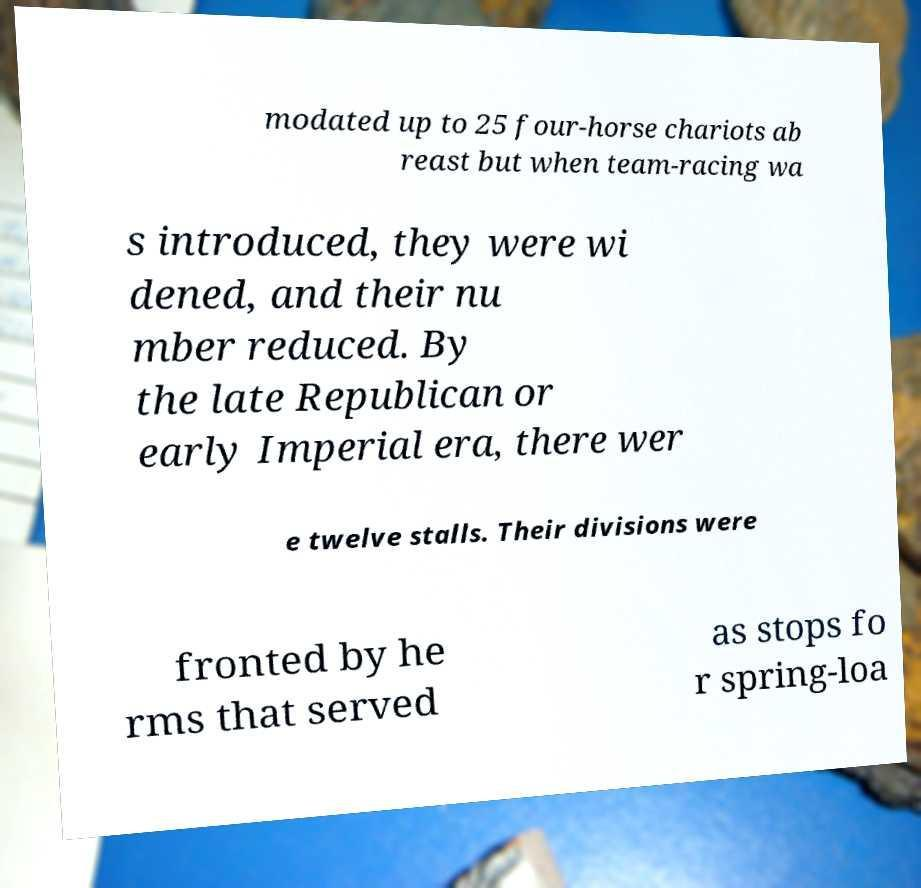I need the written content from this picture converted into text. Can you do that? modated up to 25 four-horse chariots ab reast but when team-racing wa s introduced, they were wi dened, and their nu mber reduced. By the late Republican or early Imperial era, there wer e twelve stalls. Their divisions were fronted by he rms that served as stops fo r spring-loa 